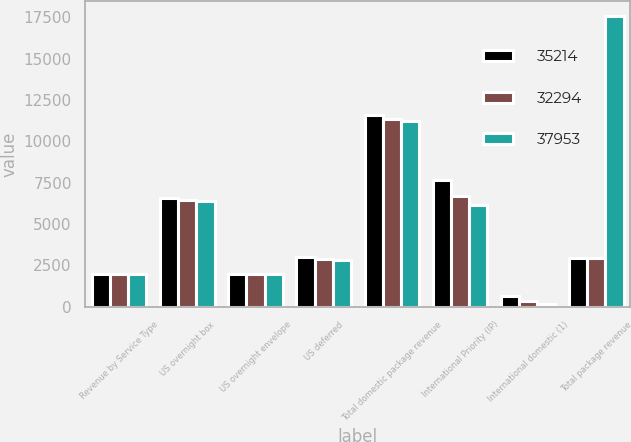<chart> <loc_0><loc_0><loc_500><loc_500><stacked_bar_chart><ecel><fcel>Revenue by Service Type<fcel>US overnight box<fcel>US overnight envelope<fcel>US deferred<fcel>Total domestic package revenue<fcel>International Priority (IP)<fcel>International domestic (1)<fcel>Total package revenue<nl><fcel>35214<fcel>2008<fcel>6578<fcel>2012<fcel>2995<fcel>11585<fcel>7666<fcel>663<fcel>2939<nl><fcel>32294<fcel>2007<fcel>6485<fcel>1990<fcel>2883<fcel>11358<fcel>6722<fcel>370<fcel>2939<nl><fcel>37953<fcel>2006<fcel>6422<fcel>1974<fcel>2853<fcel>11249<fcel>6139<fcel>199<fcel>17587<nl></chart> 